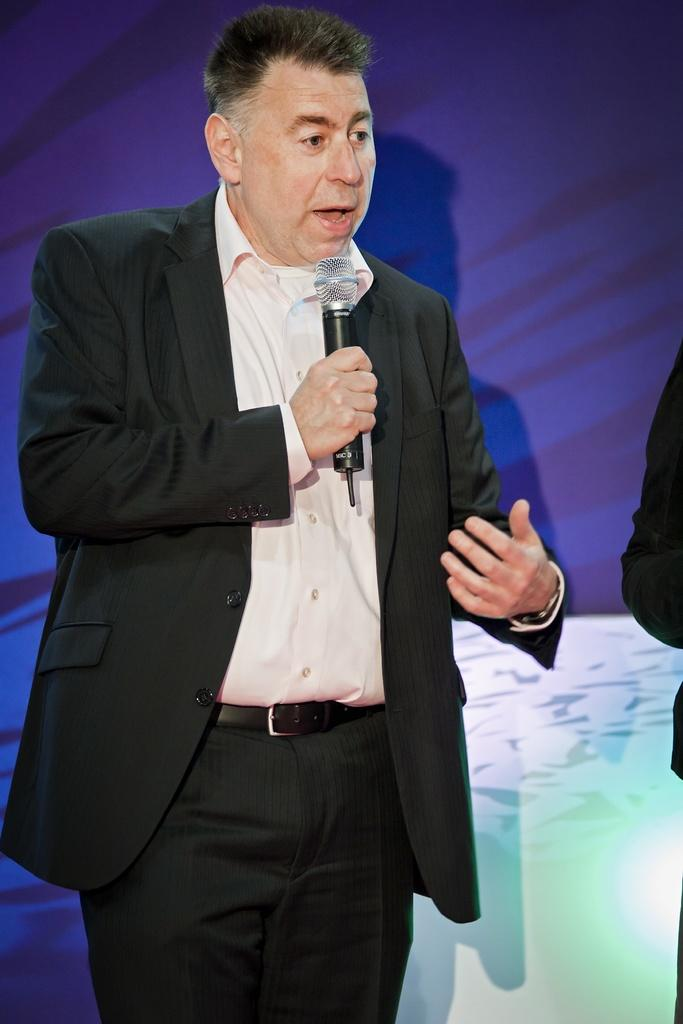What is present in the image? There is a man in the image. What is the man doing in the image? The man is standing and speaking. How is the man amplifying his voice in the image? The man is using a microphone to speak. Can you tell me how many beds are visible in the image? There are no beds present in the image. What type of lock is the man using to secure the water in the image? There is no lock or water present in the image. 